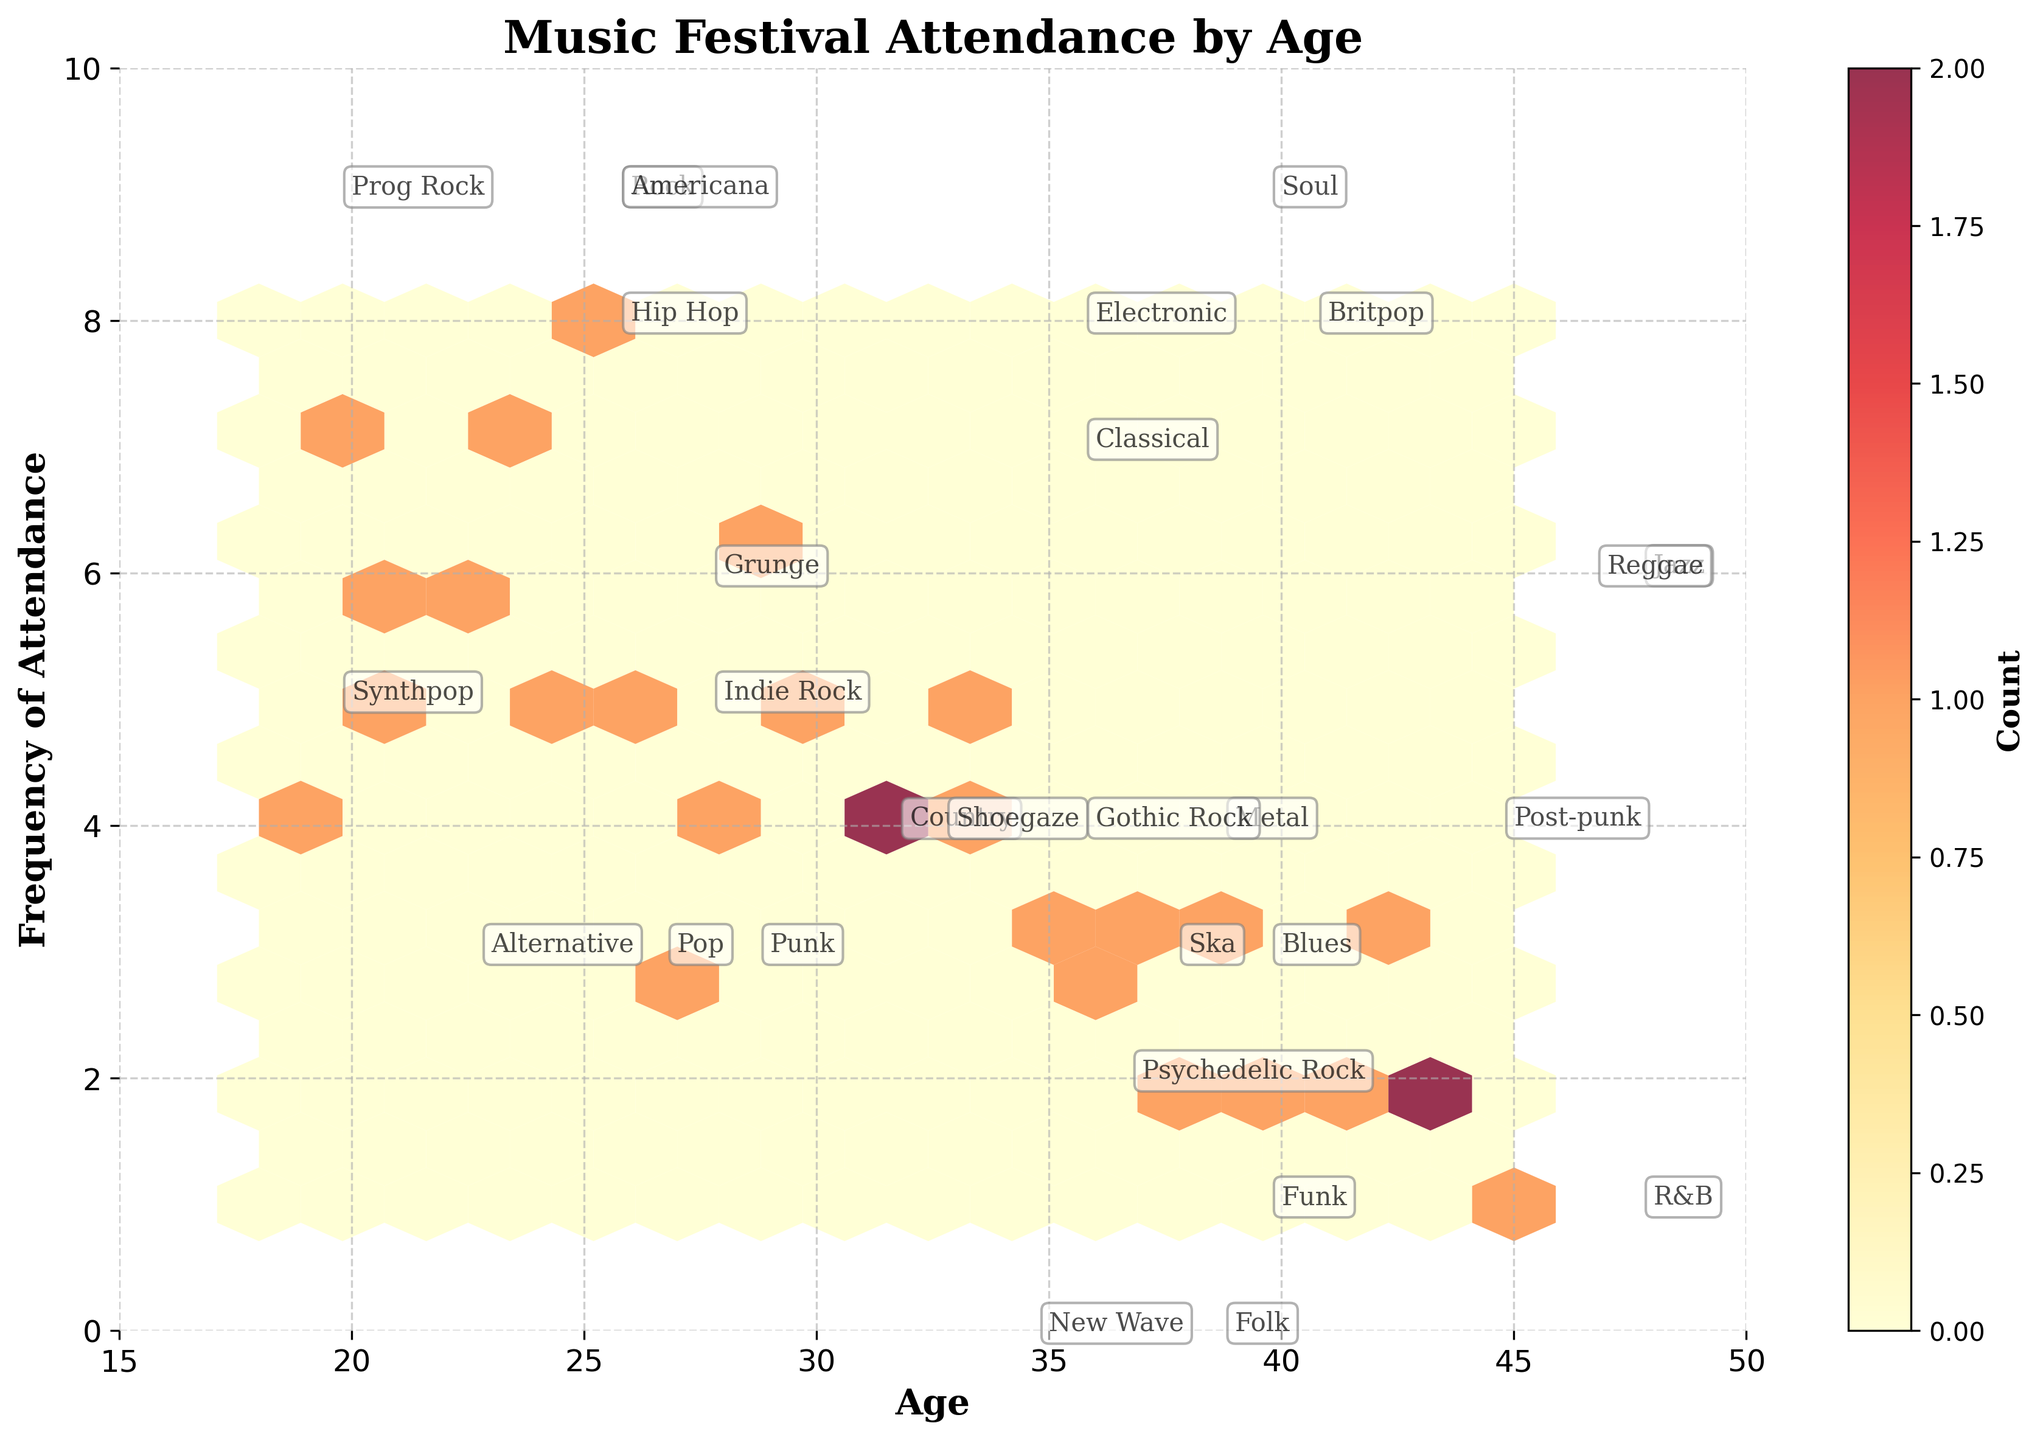What is the title of the hexbin plot? The title is usually located at the top of the figure and describes the overall topic represented by the plot. In this case, it reads "Music Festival Attendance by Age".
Answer: Music Festival Attendance by Age What are the labels on the x-axis and y-axis? The labels on the axes provide information about what each axis represents. The x-axis label is "Age", and the y-axis label is "Frequency of Attendance".
Answer: Age, Frequency of Attendance How many unique genres are annotated in the plot? Genres are annotated using text on the plot. By counting these unique labels, we can determine the number of different music genres represented. The genres listed include Indie Rock, Alternative, Electronic, etc. By listing all unique genres, we count 27 of them.
Answer: 27 What is the color range used for the hexagons in this plot? The color range of the hexagons is indicated by the color bar on the side of the plot, showing a transition from lighter to darker colors. Here, lighter colors like yellow represent lower counts, and darker colors like red represent higher counts.
Answer: Yellow to Red Which age group has the highest frequency of music festival attendance? To determine the age group with the highest frequency, look for the highest point on the y-axis (Frequency of Attendance) that aligns with an age group on the x-axis. The highest frequency of 8 is marked for the age group 25.
Answer: 25 What age range does the hexbin plot encompass? By looking at the x-axis, we can see the starting and ending values that indicate the range of ages included in the plot. The plot ranges approximately from age 15 to age 50.
Answer: 15 to 50 How does the attendance frequency for the 30-year-olds compare to that of 22-year-olds? By examining the positions on the plot, the 30-year-olds have a frequency marked at 5, while the 22-year-olds are at 6. This comparison shows 30-year-olds attend less frequently.
Answer: 22-year-olds have higher frequency What is the median frequency of attendance seen in the hexbin plot? The median frequency is the middle value when all frequencies are listed in order. Here, frequencies range from 1 to 8. Sorting them: 1, 2, 2, 2, 3, 3, 3, 3, 3, 4, 4, 4, 4, 4, 5, 5, 5, 5, 5, 6, 6, 6, 7, 7, 8. The middle value (14th in sorted list) is 4.
Answer: 4 Is there any visible trend between age and frequency of festival attendance? To identify a trend, we look at the overall distribution of hexagons. Younger age groups tend to have higher frequencies (peaking around age 25), while the frequencies generally decrease with older age groups.
Answer: Younger ages have higher frequencies Which genre annotation appears closest to the lower right corner of the hexbin plot? The lower right corner represents higher ages with lower frequencies. Checking the annotations near this area, "Prog Rock" is closest to the bottom right.
Answer: Prog Rock 